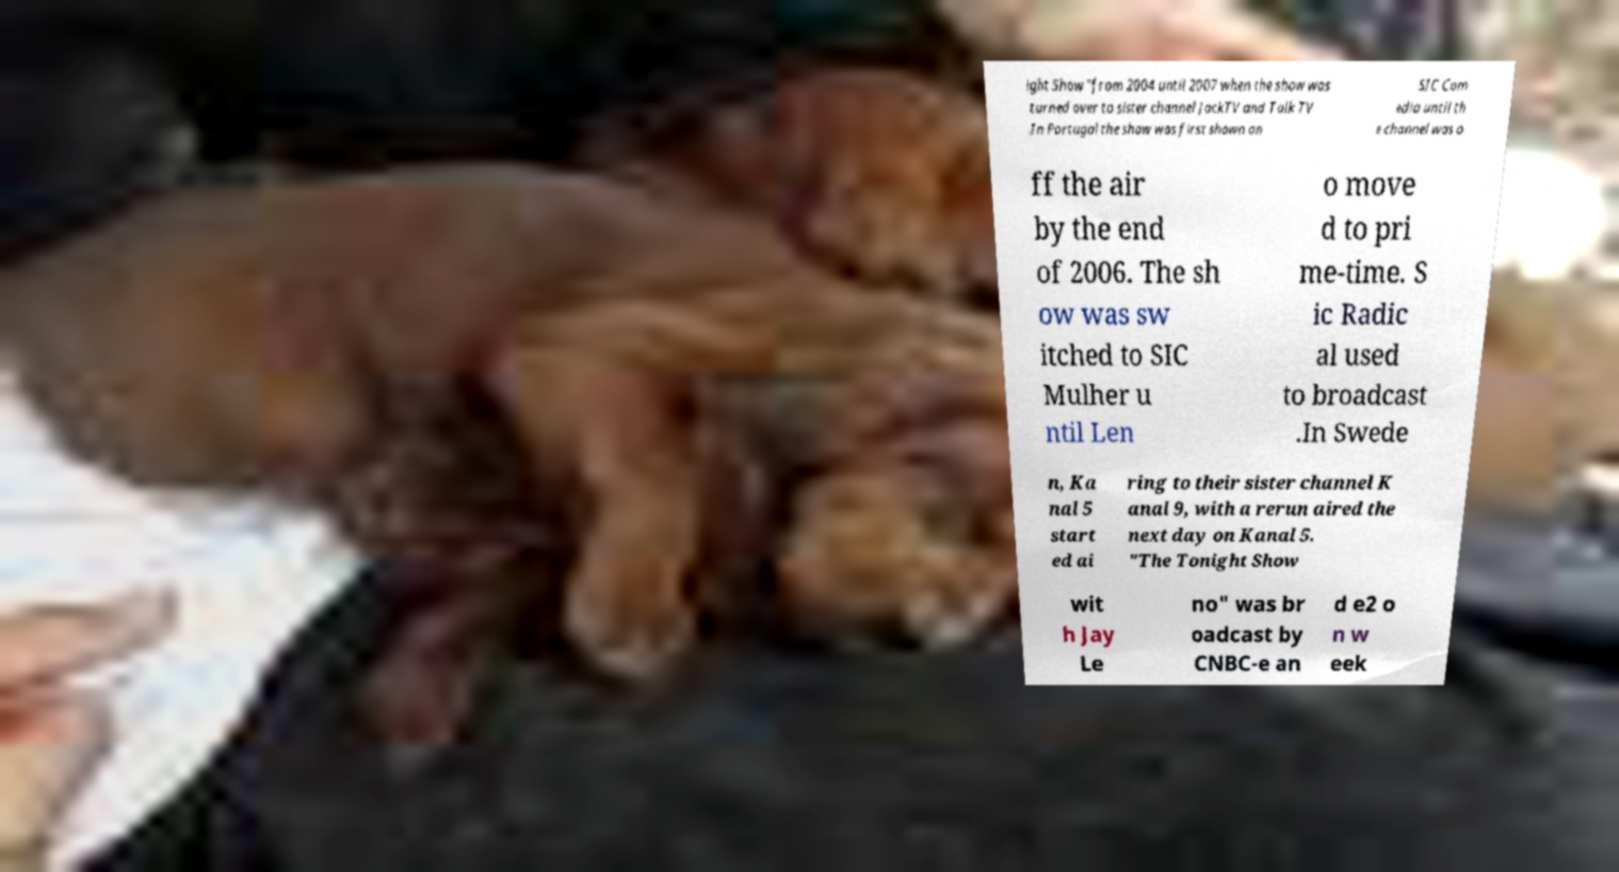Please read and relay the text visible in this image. What does it say? ight Show "from 2004 until 2007 when the show was turned over to sister channel JackTV and Talk TV .In Portugal the show was first shown on SIC Com edia until th e channel was o ff the air by the end of 2006. The sh ow was sw itched to SIC Mulher u ntil Len o move d to pri me-time. S ic Radic al used to broadcast .In Swede n, Ka nal 5 start ed ai ring to their sister channel K anal 9, with a rerun aired the next day on Kanal 5. "The Tonight Show wit h Jay Le no" was br oadcast by CNBC-e an d e2 o n w eek 